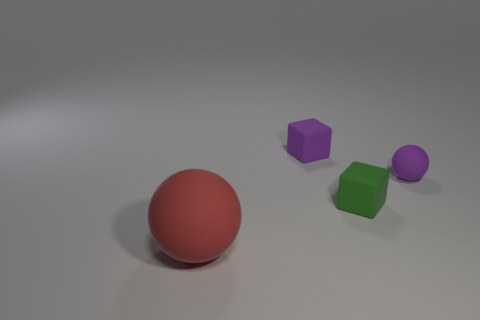Is there a blue shiny cylinder of the same size as the purple rubber ball?
Provide a succinct answer. No. Are there the same number of spheres on the right side of the large red object and blocks that are in front of the purple rubber ball?
Make the answer very short. Yes. Are there more green matte blocks than tiny gray balls?
Make the answer very short. Yes. What number of rubber objects are either small purple objects or purple spheres?
Give a very brief answer. 2. What number of tiny matte blocks are the same color as the small rubber ball?
Your answer should be compact. 1. There is a object in front of the small cube in front of the tiny purple matte thing on the left side of the green thing; what is its material?
Offer a terse response. Rubber. There is a tiny ball right of the tiny matte block that is behind the purple matte ball; what is its color?
Ensure brevity in your answer.  Purple. What number of tiny things are purple rubber spheres or purple cubes?
Your answer should be compact. 2. How many big red objects have the same material as the purple ball?
Provide a short and direct response. 1. There is a sphere in front of the small matte sphere; what size is it?
Your answer should be very brief. Large. 